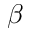Convert formula to latex. <formula><loc_0><loc_0><loc_500><loc_500>\beta</formula> 